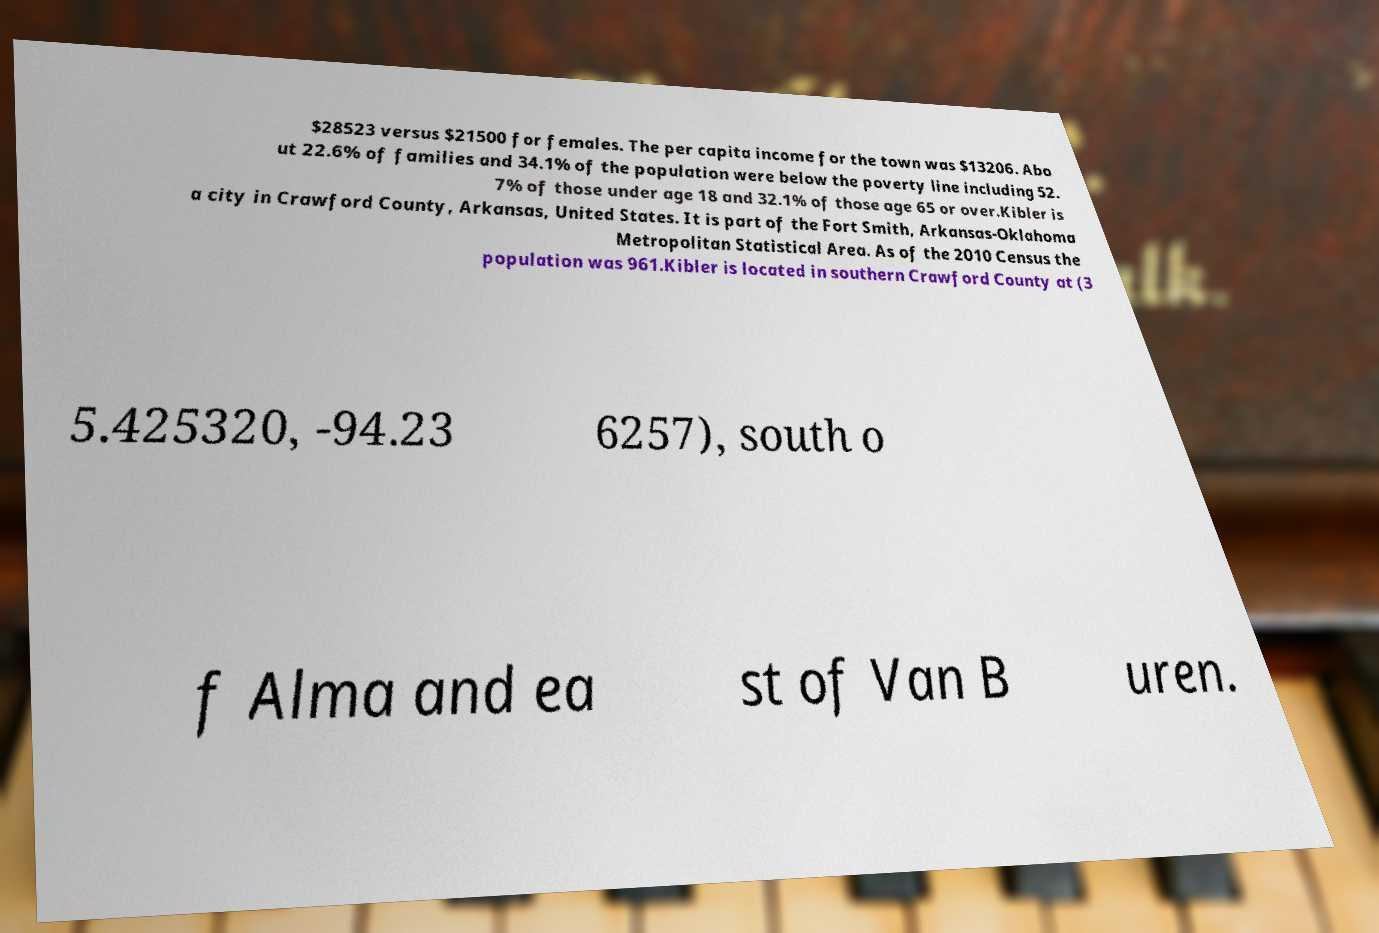I need the written content from this picture converted into text. Can you do that? $28523 versus $21500 for females. The per capita income for the town was $13206. Abo ut 22.6% of families and 34.1% of the population were below the poverty line including 52. 7% of those under age 18 and 32.1% of those age 65 or over.Kibler is a city in Crawford County, Arkansas, United States. It is part of the Fort Smith, Arkansas-Oklahoma Metropolitan Statistical Area. As of the 2010 Census the population was 961.Kibler is located in southern Crawford County at (3 5.425320, -94.23 6257), south o f Alma and ea st of Van B uren. 